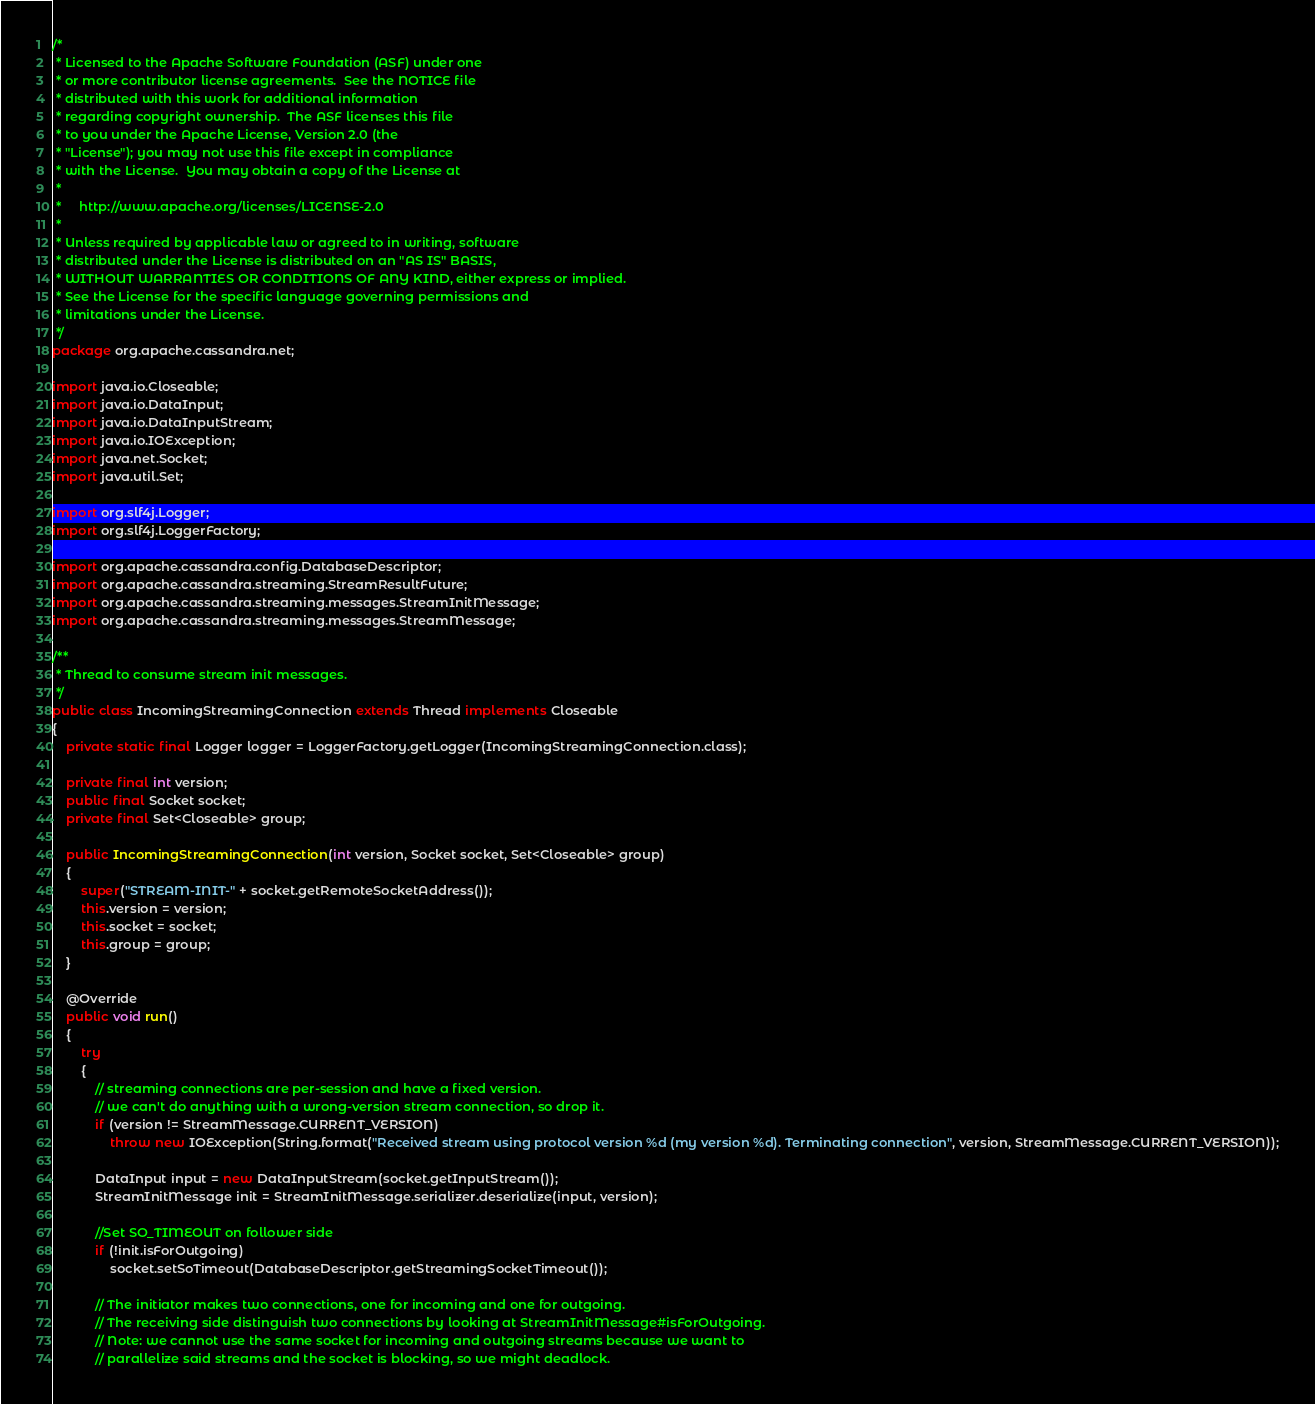Convert code to text. <code><loc_0><loc_0><loc_500><loc_500><_Java_>/*
 * Licensed to the Apache Software Foundation (ASF) under one
 * or more contributor license agreements.  See the NOTICE file
 * distributed with this work for additional information
 * regarding copyright ownership.  The ASF licenses this file
 * to you under the Apache License, Version 2.0 (the
 * "License"); you may not use this file except in compliance
 * with the License.  You may obtain a copy of the License at
 *
 *     http://www.apache.org/licenses/LICENSE-2.0
 *
 * Unless required by applicable law or agreed to in writing, software
 * distributed under the License is distributed on an "AS IS" BASIS,
 * WITHOUT WARRANTIES OR CONDITIONS OF ANY KIND, either express or implied.
 * See the License for the specific language governing permissions and
 * limitations under the License.
 */
package org.apache.cassandra.net;

import java.io.Closeable;
import java.io.DataInput;
import java.io.DataInputStream;
import java.io.IOException;
import java.net.Socket;
import java.util.Set;

import org.slf4j.Logger;
import org.slf4j.LoggerFactory;

import org.apache.cassandra.config.DatabaseDescriptor;
import org.apache.cassandra.streaming.StreamResultFuture;
import org.apache.cassandra.streaming.messages.StreamInitMessage;
import org.apache.cassandra.streaming.messages.StreamMessage;

/**
 * Thread to consume stream init messages.
 */
public class IncomingStreamingConnection extends Thread implements Closeable
{
    private static final Logger logger = LoggerFactory.getLogger(IncomingStreamingConnection.class);

    private final int version;
    public final Socket socket;
    private final Set<Closeable> group;

    public IncomingStreamingConnection(int version, Socket socket, Set<Closeable> group)
    {
        super("STREAM-INIT-" + socket.getRemoteSocketAddress());
        this.version = version;
        this.socket = socket;
        this.group = group;
    }

    @Override
    public void run()
    {
        try
        {
            // streaming connections are per-session and have a fixed version.
            // we can't do anything with a wrong-version stream connection, so drop it.
            if (version != StreamMessage.CURRENT_VERSION)
                throw new IOException(String.format("Received stream using protocol version %d (my version %d). Terminating connection", version, StreamMessage.CURRENT_VERSION));

            DataInput input = new DataInputStream(socket.getInputStream());
            StreamInitMessage init = StreamInitMessage.serializer.deserialize(input, version);

            //Set SO_TIMEOUT on follower side
            if (!init.isForOutgoing)
                socket.setSoTimeout(DatabaseDescriptor.getStreamingSocketTimeout());

            // The initiator makes two connections, one for incoming and one for outgoing.
            // The receiving side distinguish two connections by looking at StreamInitMessage#isForOutgoing.
            // Note: we cannot use the same socket for incoming and outgoing streams because we want to
            // parallelize said streams and the socket is blocking, so we might deadlock.</code> 